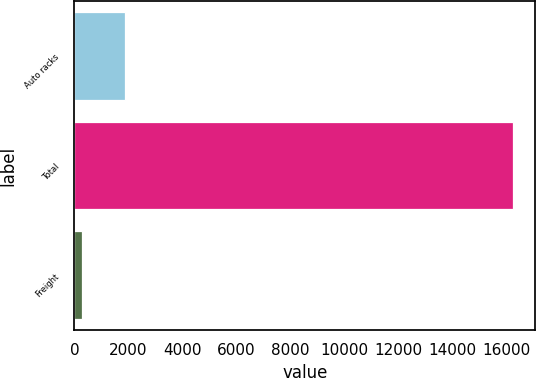<chart> <loc_0><loc_0><loc_500><loc_500><bar_chart><fcel>Auto racks<fcel>Total<fcel>Freight<nl><fcel>1869<fcel>16242<fcel>272<nl></chart> 